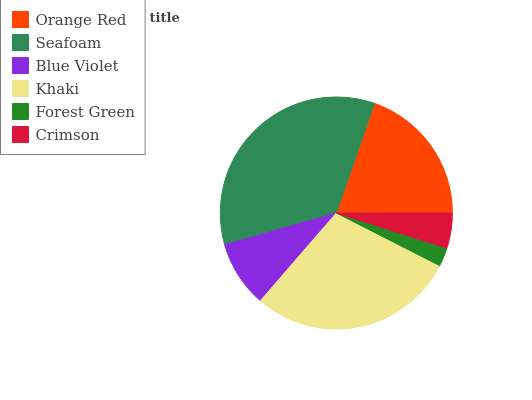Is Forest Green the minimum?
Answer yes or no. Yes. Is Seafoam the maximum?
Answer yes or no. Yes. Is Blue Violet the minimum?
Answer yes or no. No. Is Blue Violet the maximum?
Answer yes or no. No. Is Seafoam greater than Blue Violet?
Answer yes or no. Yes. Is Blue Violet less than Seafoam?
Answer yes or no. Yes. Is Blue Violet greater than Seafoam?
Answer yes or no. No. Is Seafoam less than Blue Violet?
Answer yes or no. No. Is Orange Red the high median?
Answer yes or no. Yes. Is Blue Violet the low median?
Answer yes or no. Yes. Is Blue Violet the high median?
Answer yes or no. No. Is Seafoam the low median?
Answer yes or no. No. 